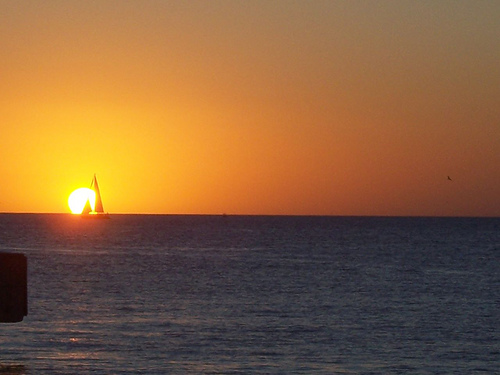<image>
Can you confirm if the sun is behind the sea? Yes. From this viewpoint, the sun is positioned behind the sea, with the sea partially or fully occluding the sun. 